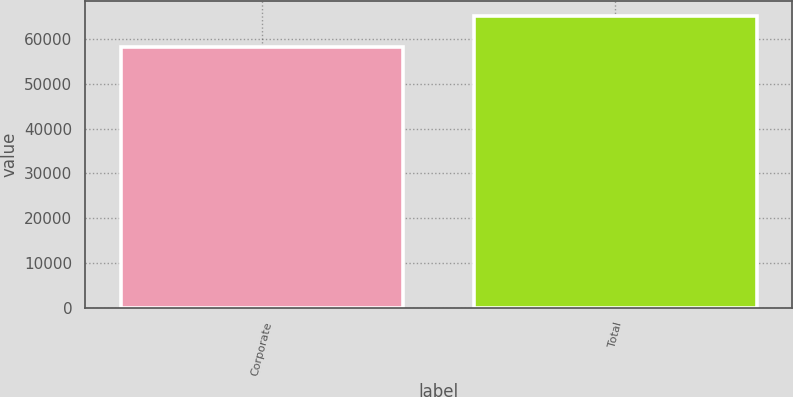Convert chart to OTSL. <chart><loc_0><loc_0><loc_500><loc_500><bar_chart><fcel>Corporate<fcel>Total<nl><fcel>58266<fcel>65218<nl></chart> 